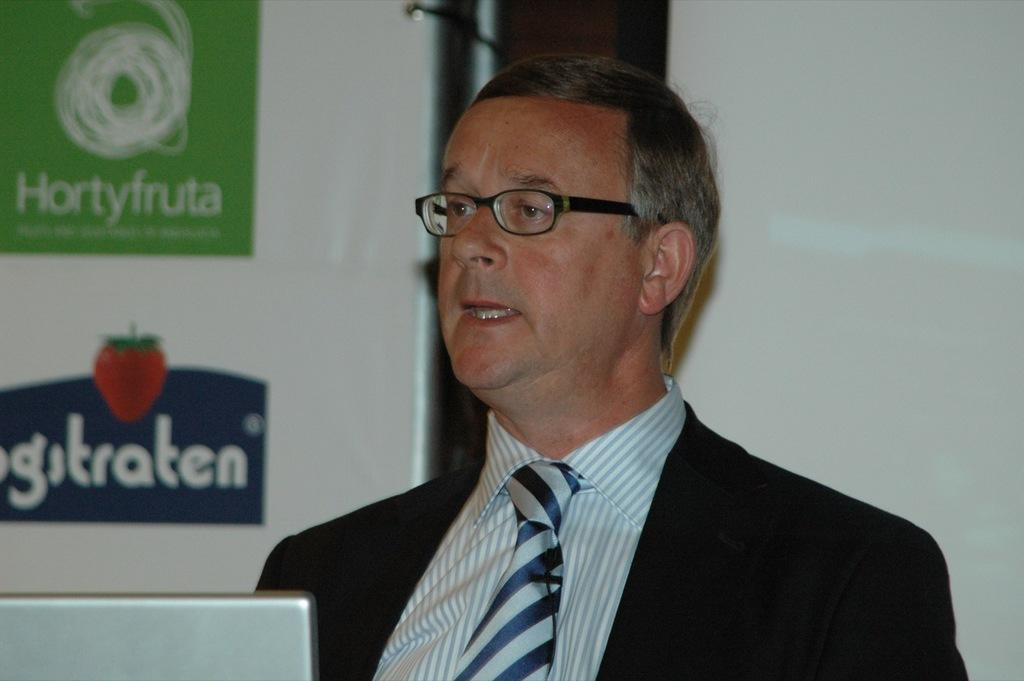What is the man in the image wearing? The man in the image is wearing a black blazer. What object is in front of the man? There is a laptop in front of the man. What is located behind the man? There is a board and a projector screen behind the man. What type of soup is being served at the cemetery in the image? There is no soup or cemetery present in the image; it features a man wearing a black blazer with a laptop in front of him and a board and projector screen behind him. 